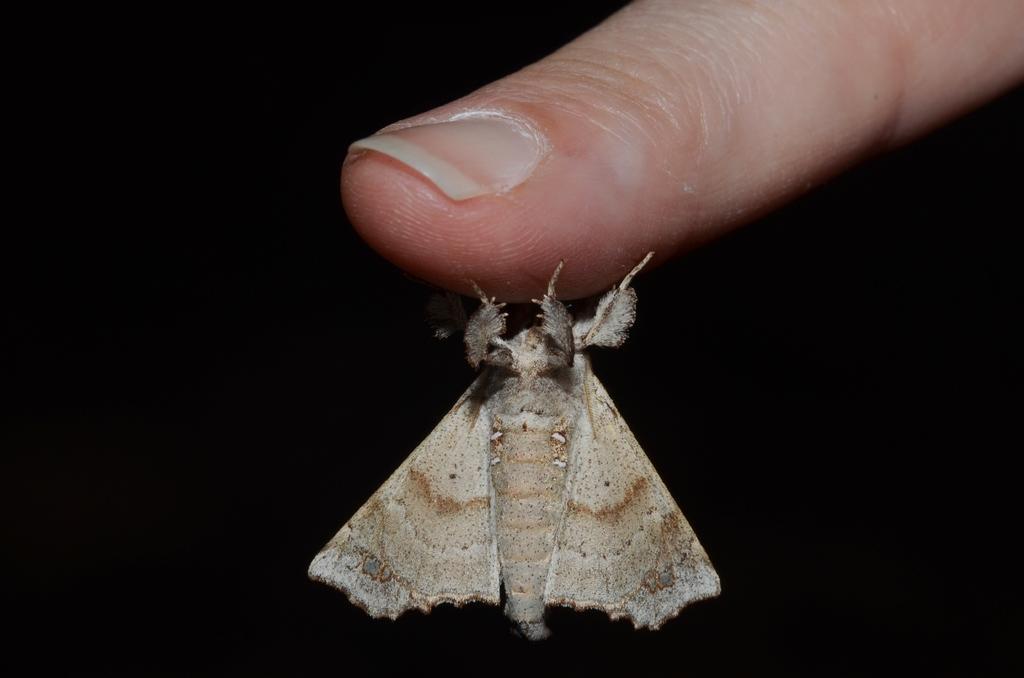How would you summarize this image in a sentence or two? In this picture, there is an insect holding the finger. It is in cream and brown in color. 